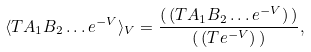Convert formula to latex. <formula><loc_0><loc_0><loc_500><loc_500>\langle T A _ { 1 } B _ { 2 } \dots e ^ { - V } \rangle _ { V } = \frac { ( \, ( T A _ { 1 } B _ { 2 } \dots e ^ { - V } ) \, ) } { ( \, ( T e ^ { - V } ) \, ) } ,</formula> 